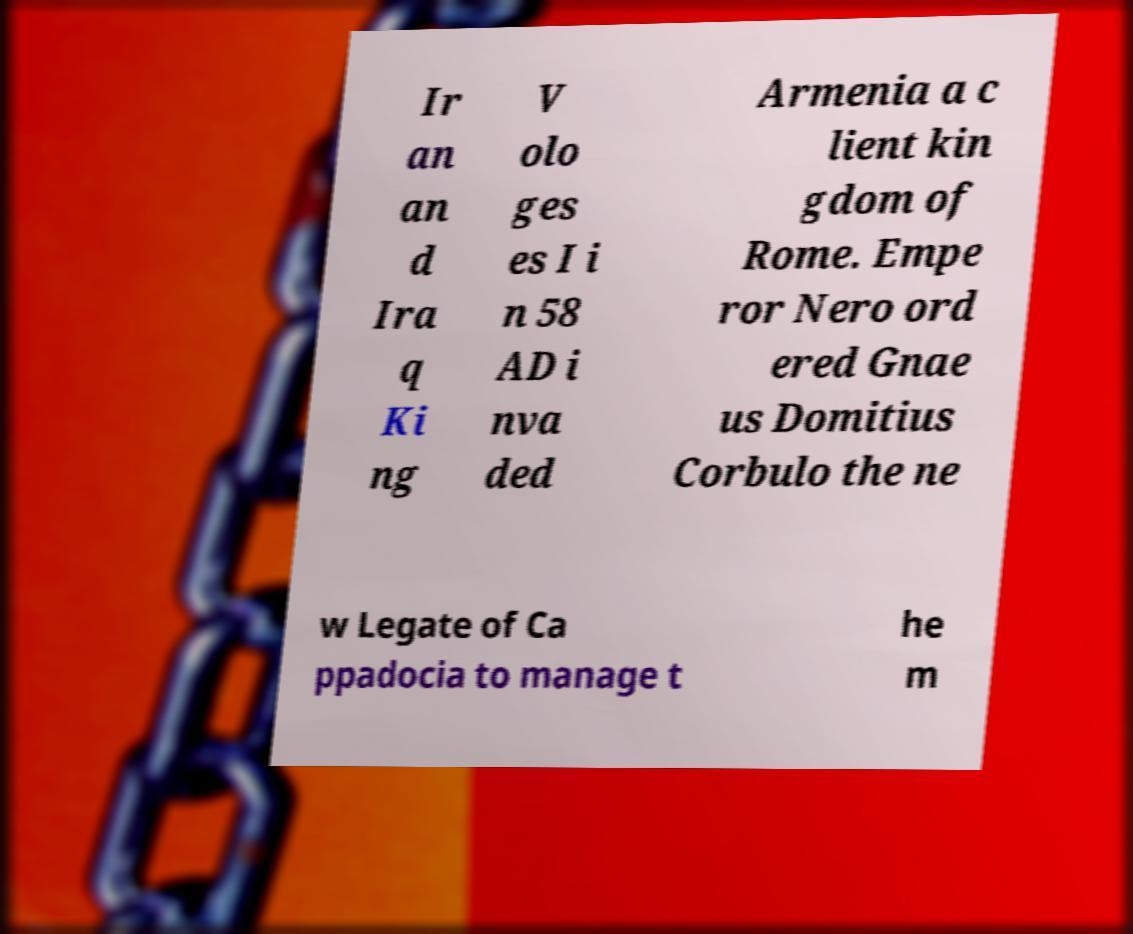Can you accurately transcribe the text from the provided image for me? Ir an an d Ira q Ki ng V olo ges es I i n 58 AD i nva ded Armenia a c lient kin gdom of Rome. Empe ror Nero ord ered Gnae us Domitius Corbulo the ne w Legate of Ca ppadocia to manage t he m 